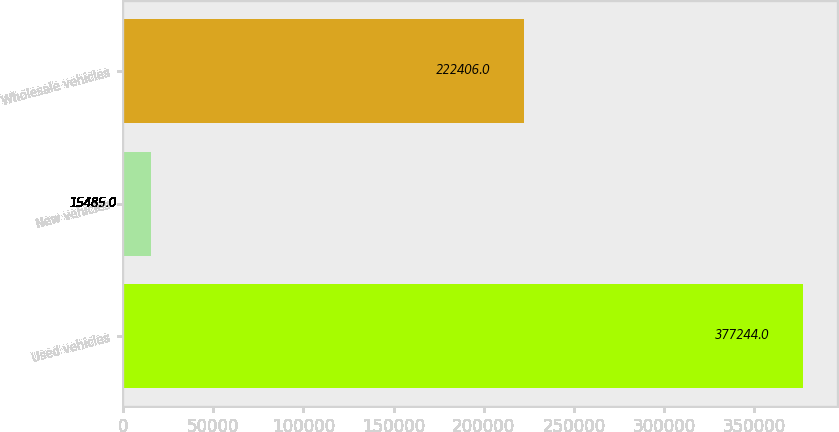Convert chart. <chart><loc_0><loc_0><loc_500><loc_500><bar_chart><fcel>Used vehicles<fcel>New vehicles<fcel>Wholesale vehicles<nl><fcel>377244<fcel>15485<fcel>222406<nl></chart> 